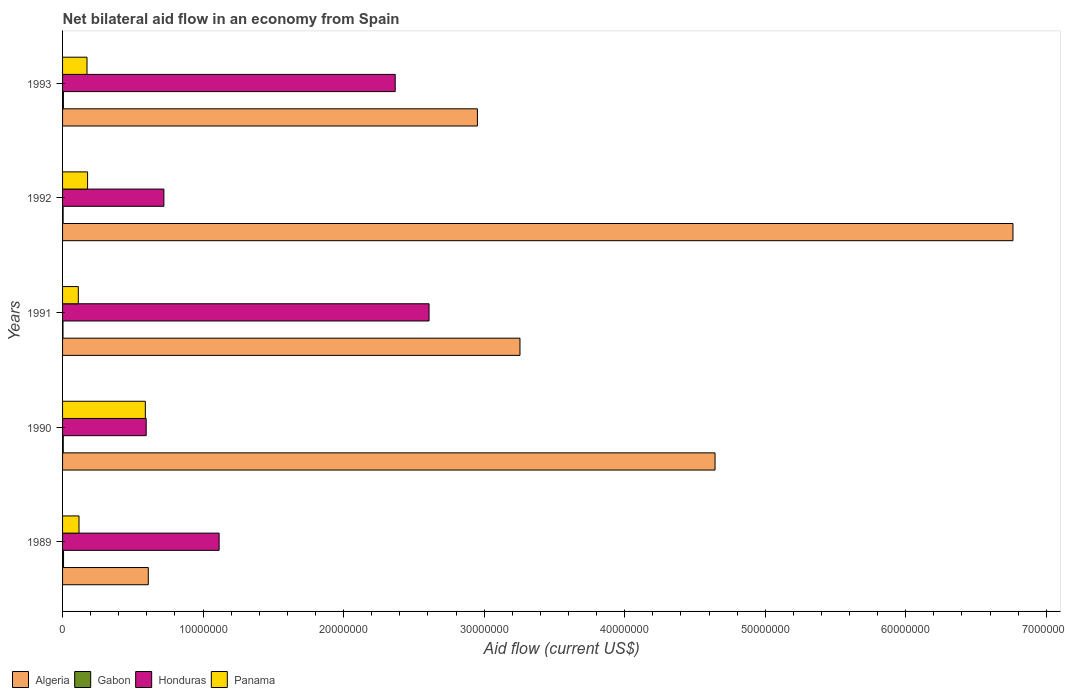How many different coloured bars are there?
Give a very brief answer. 4. How many bars are there on the 2nd tick from the bottom?
Keep it short and to the point. 4. What is the label of the 3rd group of bars from the top?
Your answer should be compact. 1991. What is the net bilateral aid flow in Gabon in 1989?
Provide a succinct answer. 7.00e+04. Across all years, what is the maximum net bilateral aid flow in Algeria?
Ensure brevity in your answer.  6.76e+07. In which year was the net bilateral aid flow in Gabon maximum?
Offer a very short reply. 1989. What is the total net bilateral aid flow in Panama in the graph?
Give a very brief answer. 1.17e+07. What is the difference between the net bilateral aid flow in Panama in 1992 and the net bilateral aid flow in Honduras in 1993?
Provide a succinct answer. -2.19e+07. What is the average net bilateral aid flow in Gabon per year?
Keep it short and to the point. 5.00e+04. In the year 1989, what is the difference between the net bilateral aid flow in Algeria and net bilateral aid flow in Gabon?
Make the answer very short. 6.03e+06. What is the ratio of the net bilateral aid flow in Algeria in 1989 to that in 1990?
Keep it short and to the point. 0.13. Is the difference between the net bilateral aid flow in Algeria in 1990 and 1992 greater than the difference between the net bilateral aid flow in Gabon in 1990 and 1992?
Offer a terse response. No. What is the difference between the highest and the lowest net bilateral aid flow in Honduras?
Provide a short and direct response. 2.01e+07. Is it the case that in every year, the sum of the net bilateral aid flow in Gabon and net bilateral aid flow in Honduras is greater than the sum of net bilateral aid flow in Algeria and net bilateral aid flow in Panama?
Keep it short and to the point. Yes. What does the 1st bar from the top in 1991 represents?
Make the answer very short. Panama. What does the 4th bar from the bottom in 1991 represents?
Offer a very short reply. Panama. How many bars are there?
Offer a very short reply. 20. How many years are there in the graph?
Make the answer very short. 5. Does the graph contain grids?
Your answer should be compact. No. Where does the legend appear in the graph?
Offer a very short reply. Bottom left. How are the legend labels stacked?
Keep it short and to the point. Horizontal. What is the title of the graph?
Ensure brevity in your answer.  Net bilateral aid flow in an economy from Spain. Does "Cameroon" appear as one of the legend labels in the graph?
Ensure brevity in your answer.  No. What is the label or title of the Y-axis?
Provide a succinct answer. Years. What is the Aid flow (current US$) of Algeria in 1989?
Ensure brevity in your answer.  6.10e+06. What is the Aid flow (current US$) in Honduras in 1989?
Your response must be concise. 1.11e+07. What is the Aid flow (current US$) of Panama in 1989?
Ensure brevity in your answer.  1.17e+06. What is the Aid flow (current US$) in Algeria in 1990?
Keep it short and to the point. 4.64e+07. What is the Aid flow (current US$) in Gabon in 1990?
Your answer should be very brief. 5.00e+04. What is the Aid flow (current US$) in Honduras in 1990?
Offer a very short reply. 5.95e+06. What is the Aid flow (current US$) in Panama in 1990?
Give a very brief answer. 5.89e+06. What is the Aid flow (current US$) in Algeria in 1991?
Make the answer very short. 3.26e+07. What is the Aid flow (current US$) of Honduras in 1991?
Your response must be concise. 2.61e+07. What is the Aid flow (current US$) of Panama in 1991?
Keep it short and to the point. 1.12e+06. What is the Aid flow (current US$) in Algeria in 1992?
Your answer should be very brief. 6.76e+07. What is the Aid flow (current US$) of Honduras in 1992?
Your answer should be compact. 7.21e+06. What is the Aid flow (current US$) of Panama in 1992?
Your answer should be very brief. 1.78e+06. What is the Aid flow (current US$) of Algeria in 1993?
Provide a short and direct response. 2.95e+07. What is the Aid flow (current US$) of Honduras in 1993?
Offer a very short reply. 2.37e+07. What is the Aid flow (current US$) of Panama in 1993?
Keep it short and to the point. 1.74e+06. Across all years, what is the maximum Aid flow (current US$) of Algeria?
Give a very brief answer. 6.76e+07. Across all years, what is the maximum Aid flow (current US$) in Honduras?
Your answer should be compact. 2.61e+07. Across all years, what is the maximum Aid flow (current US$) in Panama?
Offer a very short reply. 5.89e+06. Across all years, what is the minimum Aid flow (current US$) in Algeria?
Provide a short and direct response. 6.10e+06. Across all years, what is the minimum Aid flow (current US$) in Gabon?
Your answer should be compact. 3.00e+04. Across all years, what is the minimum Aid flow (current US$) in Honduras?
Offer a very short reply. 5.95e+06. Across all years, what is the minimum Aid flow (current US$) in Panama?
Offer a terse response. 1.12e+06. What is the total Aid flow (current US$) of Algeria in the graph?
Offer a terse response. 1.82e+08. What is the total Aid flow (current US$) of Gabon in the graph?
Keep it short and to the point. 2.50e+05. What is the total Aid flow (current US$) of Honduras in the graph?
Your answer should be very brief. 7.40e+07. What is the total Aid flow (current US$) of Panama in the graph?
Provide a succinct answer. 1.17e+07. What is the difference between the Aid flow (current US$) of Algeria in 1989 and that in 1990?
Ensure brevity in your answer.  -4.03e+07. What is the difference between the Aid flow (current US$) in Gabon in 1989 and that in 1990?
Offer a very short reply. 2.00e+04. What is the difference between the Aid flow (current US$) of Honduras in 1989 and that in 1990?
Give a very brief answer. 5.19e+06. What is the difference between the Aid flow (current US$) in Panama in 1989 and that in 1990?
Offer a terse response. -4.72e+06. What is the difference between the Aid flow (current US$) of Algeria in 1989 and that in 1991?
Provide a succinct answer. -2.64e+07. What is the difference between the Aid flow (current US$) of Gabon in 1989 and that in 1991?
Provide a short and direct response. 4.00e+04. What is the difference between the Aid flow (current US$) of Honduras in 1989 and that in 1991?
Offer a very short reply. -1.49e+07. What is the difference between the Aid flow (current US$) in Algeria in 1989 and that in 1992?
Keep it short and to the point. -6.15e+07. What is the difference between the Aid flow (current US$) of Gabon in 1989 and that in 1992?
Your answer should be very brief. 3.00e+04. What is the difference between the Aid flow (current US$) in Honduras in 1989 and that in 1992?
Your answer should be compact. 3.93e+06. What is the difference between the Aid flow (current US$) of Panama in 1989 and that in 1992?
Your answer should be compact. -6.10e+05. What is the difference between the Aid flow (current US$) of Algeria in 1989 and that in 1993?
Your response must be concise. -2.34e+07. What is the difference between the Aid flow (current US$) of Gabon in 1989 and that in 1993?
Provide a short and direct response. 10000. What is the difference between the Aid flow (current US$) in Honduras in 1989 and that in 1993?
Keep it short and to the point. -1.25e+07. What is the difference between the Aid flow (current US$) of Panama in 1989 and that in 1993?
Keep it short and to the point. -5.70e+05. What is the difference between the Aid flow (current US$) of Algeria in 1990 and that in 1991?
Ensure brevity in your answer.  1.39e+07. What is the difference between the Aid flow (current US$) in Gabon in 1990 and that in 1991?
Your response must be concise. 2.00e+04. What is the difference between the Aid flow (current US$) in Honduras in 1990 and that in 1991?
Make the answer very short. -2.01e+07. What is the difference between the Aid flow (current US$) in Panama in 1990 and that in 1991?
Offer a very short reply. 4.77e+06. What is the difference between the Aid flow (current US$) of Algeria in 1990 and that in 1992?
Your response must be concise. -2.12e+07. What is the difference between the Aid flow (current US$) in Honduras in 1990 and that in 1992?
Provide a succinct answer. -1.26e+06. What is the difference between the Aid flow (current US$) of Panama in 1990 and that in 1992?
Your answer should be compact. 4.11e+06. What is the difference between the Aid flow (current US$) of Algeria in 1990 and that in 1993?
Your response must be concise. 1.69e+07. What is the difference between the Aid flow (current US$) in Gabon in 1990 and that in 1993?
Provide a short and direct response. -10000. What is the difference between the Aid flow (current US$) of Honduras in 1990 and that in 1993?
Your answer should be compact. -1.77e+07. What is the difference between the Aid flow (current US$) in Panama in 1990 and that in 1993?
Offer a very short reply. 4.15e+06. What is the difference between the Aid flow (current US$) of Algeria in 1991 and that in 1992?
Give a very brief answer. -3.51e+07. What is the difference between the Aid flow (current US$) of Gabon in 1991 and that in 1992?
Provide a short and direct response. -10000. What is the difference between the Aid flow (current US$) in Honduras in 1991 and that in 1992?
Provide a succinct answer. 1.89e+07. What is the difference between the Aid flow (current US$) in Panama in 1991 and that in 1992?
Ensure brevity in your answer.  -6.60e+05. What is the difference between the Aid flow (current US$) in Algeria in 1991 and that in 1993?
Ensure brevity in your answer.  3.03e+06. What is the difference between the Aid flow (current US$) of Honduras in 1991 and that in 1993?
Ensure brevity in your answer.  2.41e+06. What is the difference between the Aid flow (current US$) in Panama in 1991 and that in 1993?
Provide a short and direct response. -6.20e+05. What is the difference between the Aid flow (current US$) of Algeria in 1992 and that in 1993?
Ensure brevity in your answer.  3.81e+07. What is the difference between the Aid flow (current US$) in Honduras in 1992 and that in 1993?
Ensure brevity in your answer.  -1.65e+07. What is the difference between the Aid flow (current US$) of Panama in 1992 and that in 1993?
Make the answer very short. 4.00e+04. What is the difference between the Aid flow (current US$) in Algeria in 1989 and the Aid flow (current US$) in Gabon in 1990?
Your answer should be very brief. 6.05e+06. What is the difference between the Aid flow (current US$) of Algeria in 1989 and the Aid flow (current US$) of Panama in 1990?
Offer a terse response. 2.10e+05. What is the difference between the Aid flow (current US$) in Gabon in 1989 and the Aid flow (current US$) in Honduras in 1990?
Provide a short and direct response. -5.88e+06. What is the difference between the Aid flow (current US$) in Gabon in 1989 and the Aid flow (current US$) in Panama in 1990?
Ensure brevity in your answer.  -5.82e+06. What is the difference between the Aid flow (current US$) of Honduras in 1989 and the Aid flow (current US$) of Panama in 1990?
Provide a succinct answer. 5.25e+06. What is the difference between the Aid flow (current US$) in Algeria in 1989 and the Aid flow (current US$) in Gabon in 1991?
Keep it short and to the point. 6.07e+06. What is the difference between the Aid flow (current US$) of Algeria in 1989 and the Aid flow (current US$) of Honduras in 1991?
Offer a terse response. -2.00e+07. What is the difference between the Aid flow (current US$) of Algeria in 1989 and the Aid flow (current US$) of Panama in 1991?
Offer a terse response. 4.98e+06. What is the difference between the Aid flow (current US$) in Gabon in 1989 and the Aid flow (current US$) in Honduras in 1991?
Give a very brief answer. -2.60e+07. What is the difference between the Aid flow (current US$) in Gabon in 1989 and the Aid flow (current US$) in Panama in 1991?
Provide a succinct answer. -1.05e+06. What is the difference between the Aid flow (current US$) in Honduras in 1989 and the Aid flow (current US$) in Panama in 1991?
Your answer should be compact. 1.00e+07. What is the difference between the Aid flow (current US$) in Algeria in 1989 and the Aid flow (current US$) in Gabon in 1992?
Offer a terse response. 6.06e+06. What is the difference between the Aid flow (current US$) of Algeria in 1989 and the Aid flow (current US$) of Honduras in 1992?
Offer a terse response. -1.11e+06. What is the difference between the Aid flow (current US$) in Algeria in 1989 and the Aid flow (current US$) in Panama in 1992?
Your response must be concise. 4.32e+06. What is the difference between the Aid flow (current US$) of Gabon in 1989 and the Aid flow (current US$) of Honduras in 1992?
Ensure brevity in your answer.  -7.14e+06. What is the difference between the Aid flow (current US$) of Gabon in 1989 and the Aid flow (current US$) of Panama in 1992?
Provide a succinct answer. -1.71e+06. What is the difference between the Aid flow (current US$) in Honduras in 1989 and the Aid flow (current US$) in Panama in 1992?
Provide a succinct answer. 9.36e+06. What is the difference between the Aid flow (current US$) of Algeria in 1989 and the Aid flow (current US$) of Gabon in 1993?
Your answer should be very brief. 6.04e+06. What is the difference between the Aid flow (current US$) in Algeria in 1989 and the Aid flow (current US$) in Honduras in 1993?
Your answer should be compact. -1.76e+07. What is the difference between the Aid flow (current US$) of Algeria in 1989 and the Aid flow (current US$) of Panama in 1993?
Offer a very short reply. 4.36e+06. What is the difference between the Aid flow (current US$) in Gabon in 1989 and the Aid flow (current US$) in Honduras in 1993?
Your answer should be compact. -2.36e+07. What is the difference between the Aid flow (current US$) of Gabon in 1989 and the Aid flow (current US$) of Panama in 1993?
Offer a very short reply. -1.67e+06. What is the difference between the Aid flow (current US$) in Honduras in 1989 and the Aid flow (current US$) in Panama in 1993?
Keep it short and to the point. 9.40e+06. What is the difference between the Aid flow (current US$) in Algeria in 1990 and the Aid flow (current US$) in Gabon in 1991?
Your answer should be compact. 4.64e+07. What is the difference between the Aid flow (current US$) of Algeria in 1990 and the Aid flow (current US$) of Honduras in 1991?
Make the answer very short. 2.04e+07. What is the difference between the Aid flow (current US$) in Algeria in 1990 and the Aid flow (current US$) in Panama in 1991?
Your response must be concise. 4.53e+07. What is the difference between the Aid flow (current US$) of Gabon in 1990 and the Aid flow (current US$) of Honduras in 1991?
Offer a very short reply. -2.60e+07. What is the difference between the Aid flow (current US$) in Gabon in 1990 and the Aid flow (current US$) in Panama in 1991?
Offer a very short reply. -1.07e+06. What is the difference between the Aid flow (current US$) of Honduras in 1990 and the Aid flow (current US$) of Panama in 1991?
Offer a very short reply. 4.83e+06. What is the difference between the Aid flow (current US$) of Algeria in 1990 and the Aid flow (current US$) of Gabon in 1992?
Provide a short and direct response. 4.64e+07. What is the difference between the Aid flow (current US$) of Algeria in 1990 and the Aid flow (current US$) of Honduras in 1992?
Your answer should be compact. 3.92e+07. What is the difference between the Aid flow (current US$) of Algeria in 1990 and the Aid flow (current US$) of Panama in 1992?
Your answer should be very brief. 4.46e+07. What is the difference between the Aid flow (current US$) in Gabon in 1990 and the Aid flow (current US$) in Honduras in 1992?
Provide a succinct answer. -7.16e+06. What is the difference between the Aid flow (current US$) of Gabon in 1990 and the Aid flow (current US$) of Panama in 1992?
Keep it short and to the point. -1.73e+06. What is the difference between the Aid flow (current US$) in Honduras in 1990 and the Aid flow (current US$) in Panama in 1992?
Your answer should be compact. 4.17e+06. What is the difference between the Aid flow (current US$) of Algeria in 1990 and the Aid flow (current US$) of Gabon in 1993?
Offer a terse response. 4.64e+07. What is the difference between the Aid flow (current US$) of Algeria in 1990 and the Aid flow (current US$) of Honduras in 1993?
Offer a very short reply. 2.28e+07. What is the difference between the Aid flow (current US$) in Algeria in 1990 and the Aid flow (current US$) in Panama in 1993?
Your answer should be very brief. 4.47e+07. What is the difference between the Aid flow (current US$) of Gabon in 1990 and the Aid flow (current US$) of Honduras in 1993?
Ensure brevity in your answer.  -2.36e+07. What is the difference between the Aid flow (current US$) of Gabon in 1990 and the Aid flow (current US$) of Panama in 1993?
Your answer should be very brief. -1.69e+06. What is the difference between the Aid flow (current US$) of Honduras in 1990 and the Aid flow (current US$) of Panama in 1993?
Your response must be concise. 4.21e+06. What is the difference between the Aid flow (current US$) of Algeria in 1991 and the Aid flow (current US$) of Gabon in 1992?
Give a very brief answer. 3.25e+07. What is the difference between the Aid flow (current US$) in Algeria in 1991 and the Aid flow (current US$) in Honduras in 1992?
Your response must be concise. 2.53e+07. What is the difference between the Aid flow (current US$) of Algeria in 1991 and the Aid flow (current US$) of Panama in 1992?
Provide a succinct answer. 3.08e+07. What is the difference between the Aid flow (current US$) in Gabon in 1991 and the Aid flow (current US$) in Honduras in 1992?
Offer a very short reply. -7.18e+06. What is the difference between the Aid flow (current US$) of Gabon in 1991 and the Aid flow (current US$) of Panama in 1992?
Offer a very short reply. -1.75e+06. What is the difference between the Aid flow (current US$) in Honduras in 1991 and the Aid flow (current US$) in Panama in 1992?
Your response must be concise. 2.43e+07. What is the difference between the Aid flow (current US$) in Algeria in 1991 and the Aid flow (current US$) in Gabon in 1993?
Keep it short and to the point. 3.25e+07. What is the difference between the Aid flow (current US$) in Algeria in 1991 and the Aid flow (current US$) in Honduras in 1993?
Offer a terse response. 8.88e+06. What is the difference between the Aid flow (current US$) in Algeria in 1991 and the Aid flow (current US$) in Panama in 1993?
Give a very brief answer. 3.08e+07. What is the difference between the Aid flow (current US$) of Gabon in 1991 and the Aid flow (current US$) of Honduras in 1993?
Provide a succinct answer. -2.36e+07. What is the difference between the Aid flow (current US$) in Gabon in 1991 and the Aid flow (current US$) in Panama in 1993?
Provide a succinct answer. -1.71e+06. What is the difference between the Aid flow (current US$) of Honduras in 1991 and the Aid flow (current US$) of Panama in 1993?
Your answer should be compact. 2.43e+07. What is the difference between the Aid flow (current US$) in Algeria in 1992 and the Aid flow (current US$) in Gabon in 1993?
Offer a very short reply. 6.76e+07. What is the difference between the Aid flow (current US$) of Algeria in 1992 and the Aid flow (current US$) of Honduras in 1993?
Your answer should be very brief. 4.40e+07. What is the difference between the Aid flow (current US$) of Algeria in 1992 and the Aid flow (current US$) of Panama in 1993?
Offer a terse response. 6.59e+07. What is the difference between the Aid flow (current US$) in Gabon in 1992 and the Aid flow (current US$) in Honduras in 1993?
Your answer should be compact. -2.36e+07. What is the difference between the Aid flow (current US$) of Gabon in 1992 and the Aid flow (current US$) of Panama in 1993?
Ensure brevity in your answer.  -1.70e+06. What is the difference between the Aid flow (current US$) of Honduras in 1992 and the Aid flow (current US$) of Panama in 1993?
Keep it short and to the point. 5.47e+06. What is the average Aid flow (current US$) of Algeria per year?
Provide a short and direct response. 3.64e+07. What is the average Aid flow (current US$) of Gabon per year?
Your response must be concise. 5.00e+04. What is the average Aid flow (current US$) of Honduras per year?
Provide a succinct answer. 1.48e+07. What is the average Aid flow (current US$) in Panama per year?
Your answer should be very brief. 2.34e+06. In the year 1989, what is the difference between the Aid flow (current US$) of Algeria and Aid flow (current US$) of Gabon?
Offer a terse response. 6.03e+06. In the year 1989, what is the difference between the Aid flow (current US$) in Algeria and Aid flow (current US$) in Honduras?
Ensure brevity in your answer.  -5.04e+06. In the year 1989, what is the difference between the Aid flow (current US$) of Algeria and Aid flow (current US$) of Panama?
Provide a short and direct response. 4.93e+06. In the year 1989, what is the difference between the Aid flow (current US$) in Gabon and Aid flow (current US$) in Honduras?
Provide a short and direct response. -1.11e+07. In the year 1989, what is the difference between the Aid flow (current US$) of Gabon and Aid flow (current US$) of Panama?
Ensure brevity in your answer.  -1.10e+06. In the year 1989, what is the difference between the Aid flow (current US$) in Honduras and Aid flow (current US$) in Panama?
Your response must be concise. 9.97e+06. In the year 1990, what is the difference between the Aid flow (current US$) of Algeria and Aid flow (current US$) of Gabon?
Provide a succinct answer. 4.64e+07. In the year 1990, what is the difference between the Aid flow (current US$) in Algeria and Aid flow (current US$) in Honduras?
Ensure brevity in your answer.  4.05e+07. In the year 1990, what is the difference between the Aid flow (current US$) in Algeria and Aid flow (current US$) in Panama?
Your answer should be compact. 4.05e+07. In the year 1990, what is the difference between the Aid flow (current US$) in Gabon and Aid flow (current US$) in Honduras?
Make the answer very short. -5.90e+06. In the year 1990, what is the difference between the Aid flow (current US$) in Gabon and Aid flow (current US$) in Panama?
Keep it short and to the point. -5.84e+06. In the year 1990, what is the difference between the Aid flow (current US$) in Honduras and Aid flow (current US$) in Panama?
Offer a very short reply. 6.00e+04. In the year 1991, what is the difference between the Aid flow (current US$) in Algeria and Aid flow (current US$) in Gabon?
Ensure brevity in your answer.  3.25e+07. In the year 1991, what is the difference between the Aid flow (current US$) in Algeria and Aid flow (current US$) in Honduras?
Make the answer very short. 6.47e+06. In the year 1991, what is the difference between the Aid flow (current US$) of Algeria and Aid flow (current US$) of Panama?
Your response must be concise. 3.14e+07. In the year 1991, what is the difference between the Aid flow (current US$) in Gabon and Aid flow (current US$) in Honduras?
Provide a short and direct response. -2.60e+07. In the year 1991, what is the difference between the Aid flow (current US$) in Gabon and Aid flow (current US$) in Panama?
Provide a short and direct response. -1.09e+06. In the year 1991, what is the difference between the Aid flow (current US$) of Honduras and Aid flow (current US$) of Panama?
Ensure brevity in your answer.  2.50e+07. In the year 1992, what is the difference between the Aid flow (current US$) in Algeria and Aid flow (current US$) in Gabon?
Provide a succinct answer. 6.76e+07. In the year 1992, what is the difference between the Aid flow (current US$) of Algeria and Aid flow (current US$) of Honduras?
Your response must be concise. 6.04e+07. In the year 1992, what is the difference between the Aid flow (current US$) of Algeria and Aid flow (current US$) of Panama?
Provide a short and direct response. 6.58e+07. In the year 1992, what is the difference between the Aid flow (current US$) of Gabon and Aid flow (current US$) of Honduras?
Your response must be concise. -7.17e+06. In the year 1992, what is the difference between the Aid flow (current US$) of Gabon and Aid flow (current US$) of Panama?
Ensure brevity in your answer.  -1.74e+06. In the year 1992, what is the difference between the Aid flow (current US$) of Honduras and Aid flow (current US$) of Panama?
Provide a short and direct response. 5.43e+06. In the year 1993, what is the difference between the Aid flow (current US$) in Algeria and Aid flow (current US$) in Gabon?
Ensure brevity in your answer.  2.95e+07. In the year 1993, what is the difference between the Aid flow (current US$) in Algeria and Aid flow (current US$) in Honduras?
Offer a terse response. 5.85e+06. In the year 1993, what is the difference between the Aid flow (current US$) in Algeria and Aid flow (current US$) in Panama?
Your response must be concise. 2.78e+07. In the year 1993, what is the difference between the Aid flow (current US$) in Gabon and Aid flow (current US$) in Honduras?
Provide a succinct answer. -2.36e+07. In the year 1993, what is the difference between the Aid flow (current US$) in Gabon and Aid flow (current US$) in Panama?
Offer a terse response. -1.68e+06. In the year 1993, what is the difference between the Aid flow (current US$) of Honduras and Aid flow (current US$) of Panama?
Your answer should be compact. 2.19e+07. What is the ratio of the Aid flow (current US$) in Algeria in 1989 to that in 1990?
Keep it short and to the point. 0.13. What is the ratio of the Aid flow (current US$) in Gabon in 1989 to that in 1990?
Make the answer very short. 1.4. What is the ratio of the Aid flow (current US$) of Honduras in 1989 to that in 1990?
Your answer should be compact. 1.87. What is the ratio of the Aid flow (current US$) in Panama in 1989 to that in 1990?
Your response must be concise. 0.2. What is the ratio of the Aid flow (current US$) in Algeria in 1989 to that in 1991?
Ensure brevity in your answer.  0.19. What is the ratio of the Aid flow (current US$) of Gabon in 1989 to that in 1991?
Offer a very short reply. 2.33. What is the ratio of the Aid flow (current US$) of Honduras in 1989 to that in 1991?
Your answer should be compact. 0.43. What is the ratio of the Aid flow (current US$) of Panama in 1989 to that in 1991?
Provide a short and direct response. 1.04. What is the ratio of the Aid flow (current US$) in Algeria in 1989 to that in 1992?
Offer a very short reply. 0.09. What is the ratio of the Aid flow (current US$) in Gabon in 1989 to that in 1992?
Offer a very short reply. 1.75. What is the ratio of the Aid flow (current US$) of Honduras in 1989 to that in 1992?
Keep it short and to the point. 1.55. What is the ratio of the Aid flow (current US$) in Panama in 1989 to that in 1992?
Offer a terse response. 0.66. What is the ratio of the Aid flow (current US$) in Algeria in 1989 to that in 1993?
Keep it short and to the point. 0.21. What is the ratio of the Aid flow (current US$) of Gabon in 1989 to that in 1993?
Ensure brevity in your answer.  1.17. What is the ratio of the Aid flow (current US$) in Honduras in 1989 to that in 1993?
Give a very brief answer. 0.47. What is the ratio of the Aid flow (current US$) of Panama in 1989 to that in 1993?
Provide a short and direct response. 0.67. What is the ratio of the Aid flow (current US$) in Algeria in 1990 to that in 1991?
Offer a very short reply. 1.43. What is the ratio of the Aid flow (current US$) of Honduras in 1990 to that in 1991?
Ensure brevity in your answer.  0.23. What is the ratio of the Aid flow (current US$) in Panama in 1990 to that in 1991?
Your answer should be compact. 5.26. What is the ratio of the Aid flow (current US$) in Algeria in 1990 to that in 1992?
Provide a short and direct response. 0.69. What is the ratio of the Aid flow (current US$) of Honduras in 1990 to that in 1992?
Offer a terse response. 0.83. What is the ratio of the Aid flow (current US$) of Panama in 1990 to that in 1992?
Your answer should be very brief. 3.31. What is the ratio of the Aid flow (current US$) of Algeria in 1990 to that in 1993?
Provide a succinct answer. 1.57. What is the ratio of the Aid flow (current US$) of Gabon in 1990 to that in 1993?
Offer a very short reply. 0.83. What is the ratio of the Aid flow (current US$) of Honduras in 1990 to that in 1993?
Your response must be concise. 0.25. What is the ratio of the Aid flow (current US$) in Panama in 1990 to that in 1993?
Your response must be concise. 3.39. What is the ratio of the Aid flow (current US$) in Algeria in 1991 to that in 1992?
Your answer should be compact. 0.48. What is the ratio of the Aid flow (current US$) of Gabon in 1991 to that in 1992?
Your response must be concise. 0.75. What is the ratio of the Aid flow (current US$) of Honduras in 1991 to that in 1992?
Offer a terse response. 3.62. What is the ratio of the Aid flow (current US$) in Panama in 1991 to that in 1992?
Keep it short and to the point. 0.63. What is the ratio of the Aid flow (current US$) in Algeria in 1991 to that in 1993?
Your answer should be compact. 1.1. What is the ratio of the Aid flow (current US$) of Honduras in 1991 to that in 1993?
Offer a very short reply. 1.1. What is the ratio of the Aid flow (current US$) of Panama in 1991 to that in 1993?
Make the answer very short. 0.64. What is the ratio of the Aid flow (current US$) in Algeria in 1992 to that in 1993?
Ensure brevity in your answer.  2.29. What is the ratio of the Aid flow (current US$) in Gabon in 1992 to that in 1993?
Provide a short and direct response. 0.67. What is the ratio of the Aid flow (current US$) of Honduras in 1992 to that in 1993?
Ensure brevity in your answer.  0.3. What is the difference between the highest and the second highest Aid flow (current US$) of Algeria?
Your answer should be compact. 2.12e+07. What is the difference between the highest and the second highest Aid flow (current US$) in Honduras?
Your response must be concise. 2.41e+06. What is the difference between the highest and the second highest Aid flow (current US$) in Panama?
Offer a terse response. 4.11e+06. What is the difference between the highest and the lowest Aid flow (current US$) in Algeria?
Provide a short and direct response. 6.15e+07. What is the difference between the highest and the lowest Aid flow (current US$) in Honduras?
Make the answer very short. 2.01e+07. What is the difference between the highest and the lowest Aid flow (current US$) in Panama?
Offer a terse response. 4.77e+06. 